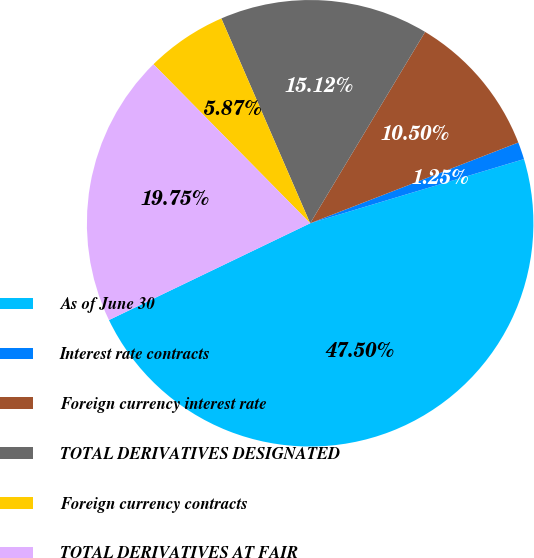Convert chart to OTSL. <chart><loc_0><loc_0><loc_500><loc_500><pie_chart><fcel>As of June 30<fcel>Interest rate contracts<fcel>Foreign currency interest rate<fcel>TOTAL DERIVATIVES DESIGNATED<fcel>Foreign currency contracts<fcel>TOTAL DERIVATIVES AT FAIR<nl><fcel>47.5%<fcel>1.25%<fcel>10.5%<fcel>15.12%<fcel>5.87%<fcel>19.75%<nl></chart> 